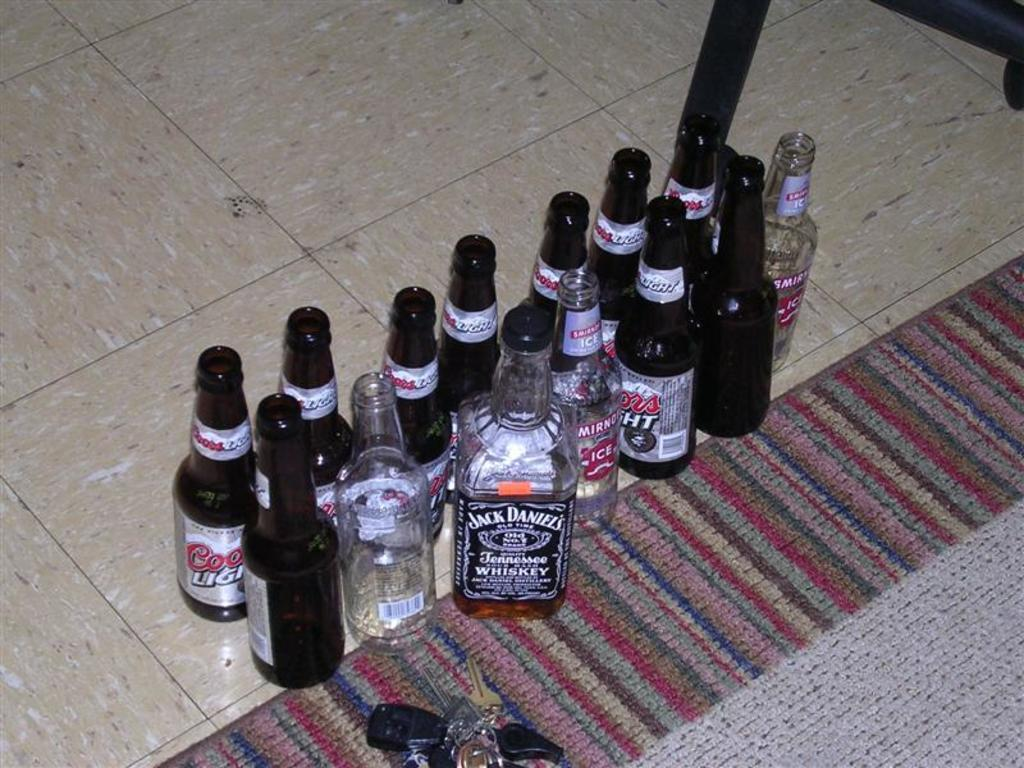<image>
Provide a brief description of the given image. many bottles of alcohol and one of Jack Daniels 